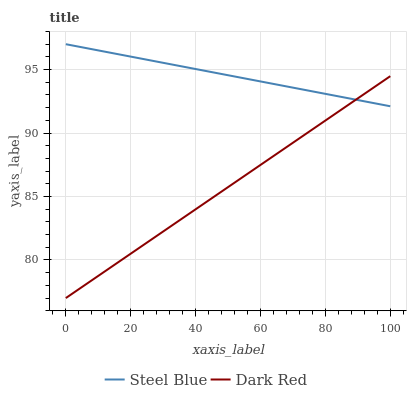Does Dark Red have the minimum area under the curve?
Answer yes or no. Yes. Does Steel Blue have the maximum area under the curve?
Answer yes or no. Yes. Does Steel Blue have the minimum area under the curve?
Answer yes or no. No. Is Dark Red the smoothest?
Answer yes or no. Yes. Is Steel Blue the roughest?
Answer yes or no. Yes. Is Steel Blue the smoothest?
Answer yes or no. No. Does Dark Red have the lowest value?
Answer yes or no. Yes. Does Steel Blue have the lowest value?
Answer yes or no. No. Does Steel Blue have the highest value?
Answer yes or no. Yes. Does Dark Red intersect Steel Blue?
Answer yes or no. Yes. Is Dark Red less than Steel Blue?
Answer yes or no. No. Is Dark Red greater than Steel Blue?
Answer yes or no. No. 